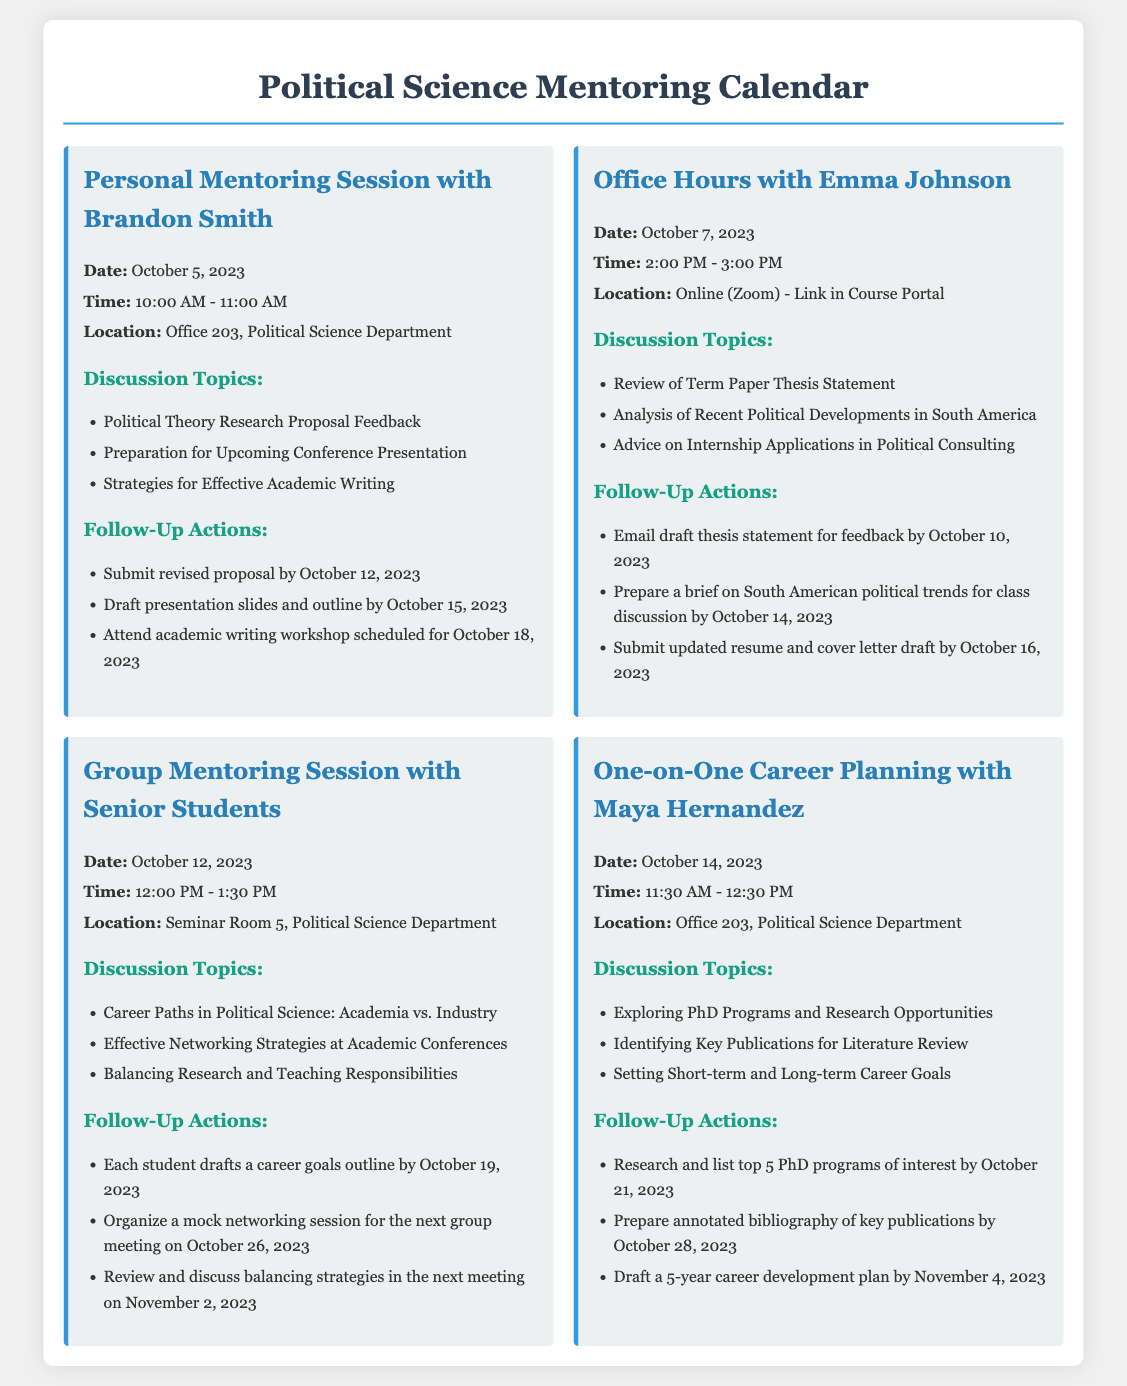What is the date of the personal mentoring session with Brandon Smith? The date for the session can be found in the event details, which states October 5, 2023.
Answer: October 5, 2023 What time are the office hours with Emma Johnson? The time is listed in the event description, which shows the office hours occur from 2:00 PM to 3:00 PM.
Answer: 2:00 PM - 3:00 PM Where is the location for the group mentoring session? The location can be found in the event details, specifying it will take place in Seminar Room 5, Political Science Department.
Answer: Seminar Room 5, Political Science Department What is one discussion topic for the personal mentoring session with Brandon Smith? One of the topics is mentioned in the discussion topics section, specifically "Political Theory Research Proposal Feedback."
Answer: Political Theory Research Proposal Feedback How many follow-up actions are listed for the group mentoring session? By counting the follow-up actions under the group mentoring session, there are three listed actions.
Answer: Three What is a major focus during the one-on-one career planning with Maya Hernandez? The session includes a focus on "Exploring PhD Programs and Research Opportunities," which is one of the discussion topics.
Answer: Exploring PhD Programs and Research Opportunities When is the deadline to submit the revised proposal discussed with Brandon Smith? The follow-up actions section indicates the revised proposal is to be submitted by October 12, 2023.
Answer: October 12, 2023 What is one follow-up action for the office hours with Emma Johnson? One specific action listed is to "Email draft thesis statement for feedback by October 10, 2023."
Answer: Email draft thesis statement for feedback by October 10, 2023 How long is the group mentoring session scheduled for? The length of the session is indicated by the time frame provided, which shows it lasts for 1 hour and 30 minutes.
Answer: 1 hour and 30 minutes 